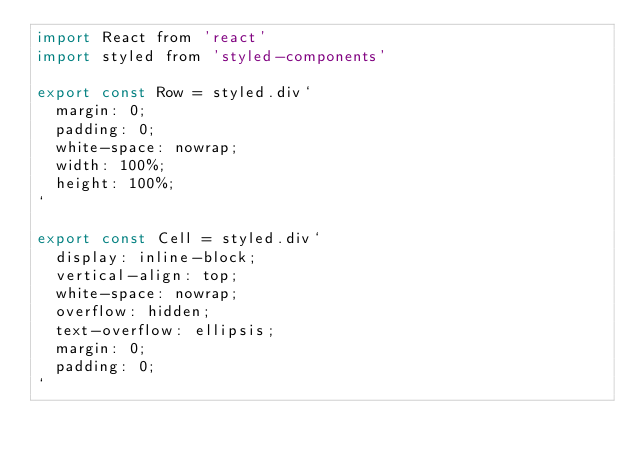<code> <loc_0><loc_0><loc_500><loc_500><_JavaScript_>import React from 'react'
import styled from 'styled-components'

export const Row = styled.div`
  margin: 0;
  padding: 0;
  white-space: nowrap;
  width: 100%;
  height: 100%;
`

export const Cell = styled.div`
  display: inline-block;
  vertical-align: top;
  white-space: nowrap;
  overflow: hidden;
  text-overflow: ellipsis;
  margin: 0;
  padding: 0;
`
</code> 